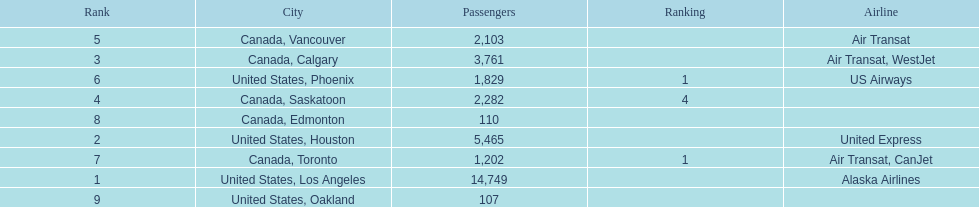The difference in passengers between los angeles and toronto 13,547. 